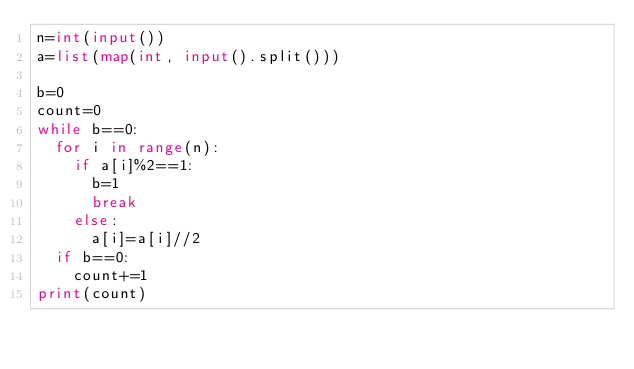<code> <loc_0><loc_0><loc_500><loc_500><_Python_>n=int(input())
a=list(map(int, input().split()))

b=0
count=0
while b==0:
  for i in range(n):
    if a[i]%2==1:
      b=1
      break
    else:
      a[i]=a[i]//2
  if b==0:
    count+=1
print(count)</code> 